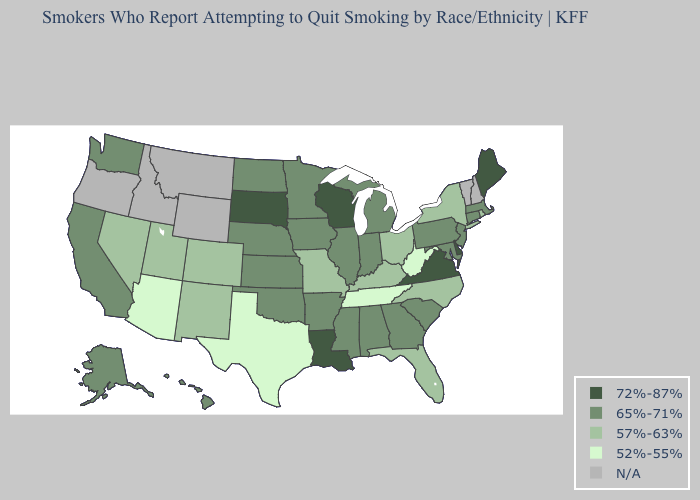What is the value of Kansas?
Answer briefly. 65%-71%. What is the lowest value in the USA?
Answer briefly. 52%-55%. What is the value of New Mexico?
Short answer required. 57%-63%. What is the lowest value in the West?
Give a very brief answer. 52%-55%. Does Ohio have the lowest value in the MidWest?
Give a very brief answer. Yes. What is the value of Nebraska?
Be succinct. 65%-71%. What is the value of Georgia?
Write a very short answer. 65%-71%. What is the highest value in the USA?
Concise answer only. 72%-87%. What is the value of New Jersey?
Quick response, please. 65%-71%. Among the states that border Utah , does Arizona have the highest value?
Quick response, please. No. Which states have the lowest value in the MidWest?
Short answer required. Missouri, Ohio. What is the lowest value in the West?
Keep it brief. 52%-55%. What is the highest value in states that border Nebraska?
Be succinct. 72%-87%. Among the states that border Ohio , which have the highest value?
Keep it brief. Indiana, Michigan, Pennsylvania. What is the highest value in the USA?
Quick response, please. 72%-87%. 